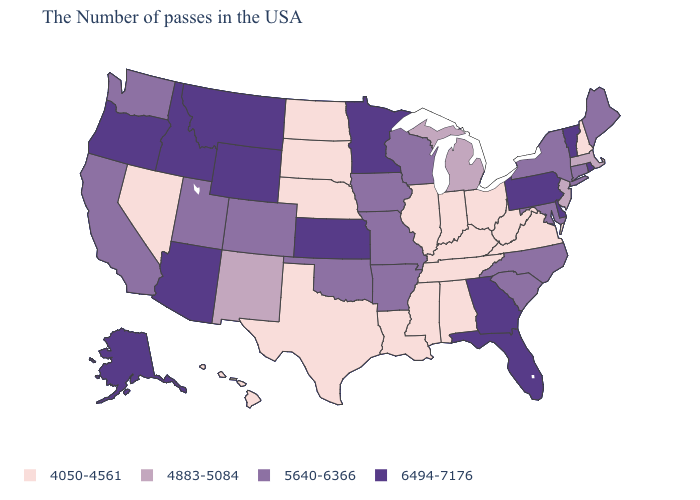Does Montana have the highest value in the USA?
Concise answer only. Yes. What is the highest value in the USA?
Quick response, please. 6494-7176. Among the states that border Louisiana , does Arkansas have the lowest value?
Be succinct. No. What is the value of Indiana?
Short answer required. 4050-4561. Name the states that have a value in the range 5640-6366?
Be succinct. Maine, Connecticut, New York, Maryland, North Carolina, South Carolina, Wisconsin, Missouri, Arkansas, Iowa, Oklahoma, Colorado, Utah, California, Washington. Name the states that have a value in the range 4883-5084?
Quick response, please. Massachusetts, New Jersey, Michigan, New Mexico. Does the first symbol in the legend represent the smallest category?
Short answer required. Yes. What is the highest value in the West ?
Be succinct. 6494-7176. Name the states that have a value in the range 4050-4561?
Write a very short answer. New Hampshire, Virginia, West Virginia, Ohio, Kentucky, Indiana, Alabama, Tennessee, Illinois, Mississippi, Louisiana, Nebraska, Texas, South Dakota, North Dakota, Nevada, Hawaii. Among the states that border Michigan , does Indiana have the lowest value?
Quick response, please. Yes. Which states have the lowest value in the USA?
Concise answer only. New Hampshire, Virginia, West Virginia, Ohio, Kentucky, Indiana, Alabama, Tennessee, Illinois, Mississippi, Louisiana, Nebraska, Texas, South Dakota, North Dakota, Nevada, Hawaii. Name the states that have a value in the range 5640-6366?
Concise answer only. Maine, Connecticut, New York, Maryland, North Carolina, South Carolina, Wisconsin, Missouri, Arkansas, Iowa, Oklahoma, Colorado, Utah, California, Washington. What is the value of Oregon?
Keep it brief. 6494-7176. Among the states that border Mississippi , which have the lowest value?
Quick response, please. Alabama, Tennessee, Louisiana. Name the states that have a value in the range 5640-6366?
Give a very brief answer. Maine, Connecticut, New York, Maryland, North Carolina, South Carolina, Wisconsin, Missouri, Arkansas, Iowa, Oklahoma, Colorado, Utah, California, Washington. 